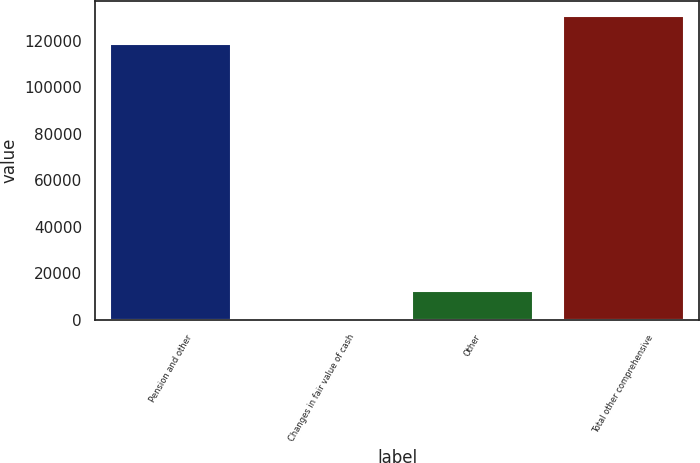Convert chart. <chart><loc_0><loc_0><loc_500><loc_500><bar_chart><fcel>Pension and other<fcel>Changes in fair value of cash<fcel>Other<fcel>Total other comprehensive<nl><fcel>118507<fcel>49<fcel>12307<fcel>130765<nl></chart> 